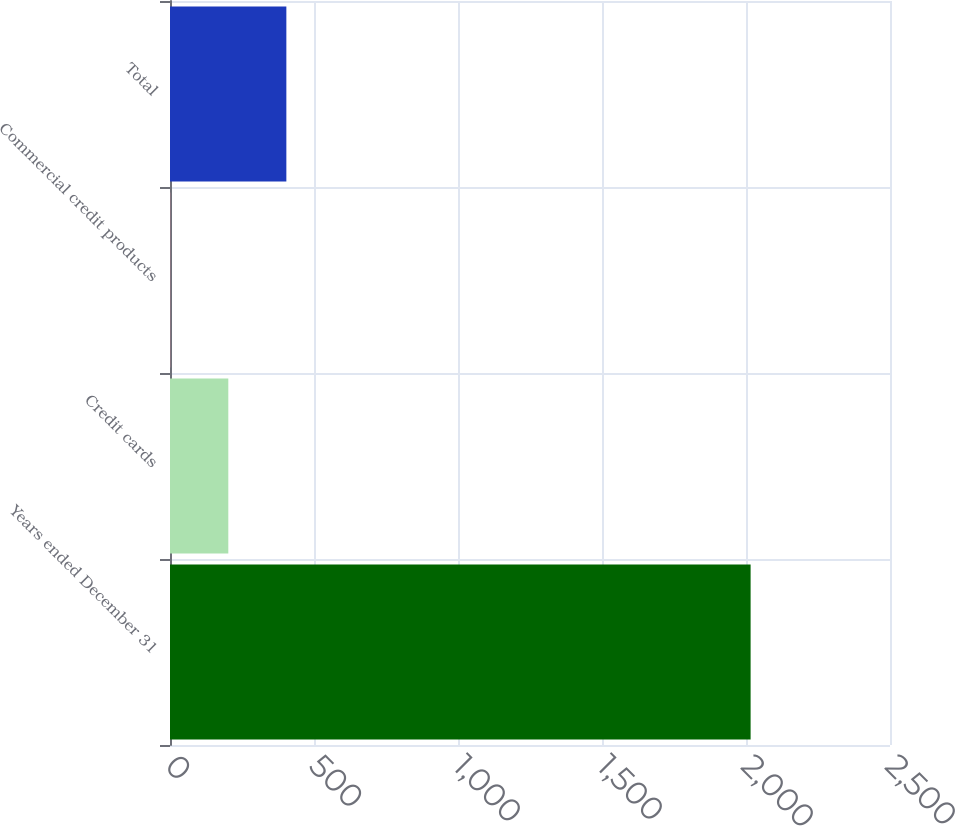Convert chart. <chart><loc_0><loc_0><loc_500><loc_500><bar_chart><fcel>Years ended December 31<fcel>Credit cards<fcel>Commercial credit products<fcel>Total<nl><fcel>2016<fcel>202.5<fcel>1<fcel>404<nl></chart> 